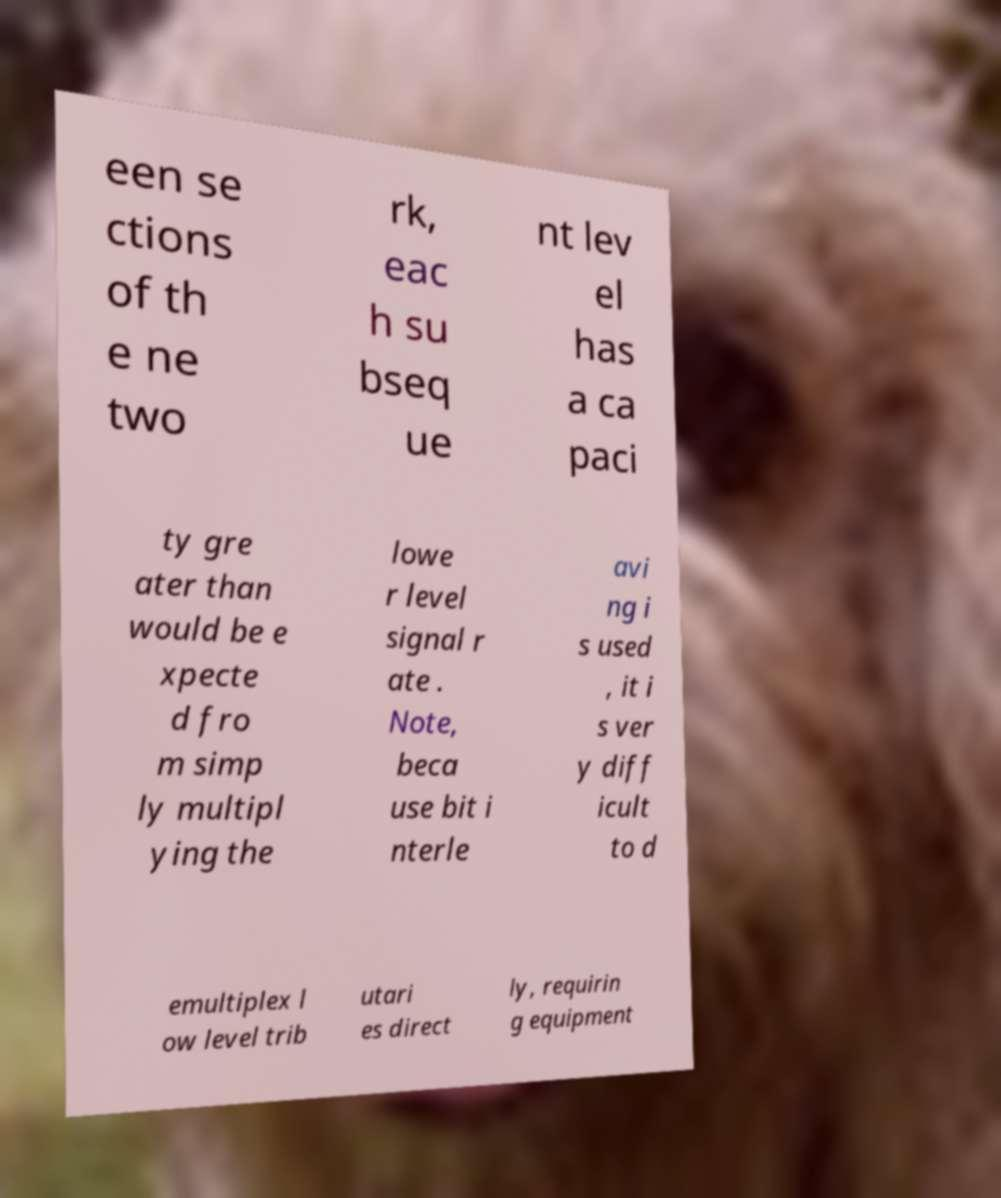Could you extract and type out the text from this image? een se ctions of th e ne two rk, eac h su bseq ue nt lev el has a ca paci ty gre ater than would be e xpecte d fro m simp ly multipl ying the lowe r level signal r ate . Note, beca use bit i nterle avi ng i s used , it i s ver y diff icult to d emultiplex l ow level trib utari es direct ly, requirin g equipment 